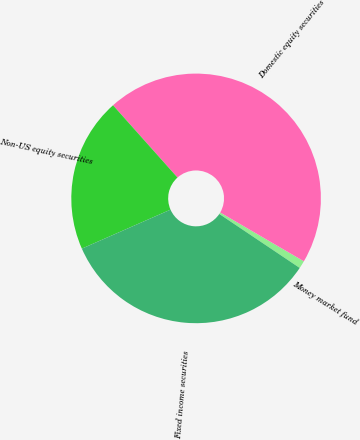Convert chart to OTSL. <chart><loc_0><loc_0><loc_500><loc_500><pie_chart><fcel>Money market fund<fcel>Domestic equity securities<fcel>Non-US equity securities<fcel>Fixed income securities<nl><fcel>1.0%<fcel>45.0%<fcel>20.0%<fcel>34.0%<nl></chart> 